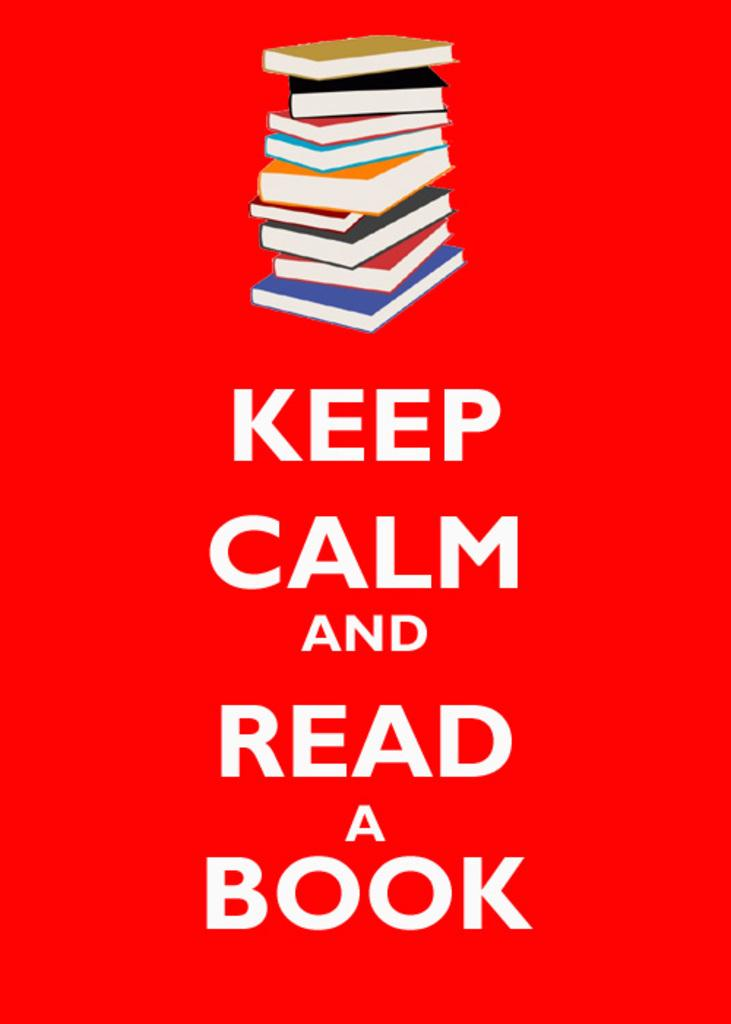<image>
Share a concise interpretation of the image provided. A stack of books on a red background advertising reading more. 